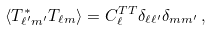<formula> <loc_0><loc_0><loc_500><loc_500>\langle T _ { \ell ^ { \prime } m ^ { \prime } } ^ { * } T _ { \ell m } \rangle = C _ { \ell } ^ { T T } \delta _ { \ell \ell ^ { \prime } } \delta _ { m m ^ { \prime } } \, ,</formula> 